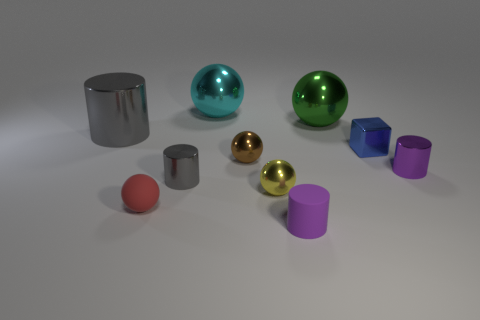Subtract all purple shiny cylinders. How many cylinders are left? 3 Subtract all gray balls. How many gray cylinders are left? 2 Subtract all cyan spheres. How many spheres are left? 4 Subtract 2 cylinders. How many cylinders are left? 2 Subtract all cylinders. How many objects are left? 6 Subtract 0 purple blocks. How many objects are left? 10 Subtract all blue cylinders. Subtract all blue spheres. How many cylinders are left? 4 Subtract all big green shiny spheres. Subtract all cyan metal balls. How many objects are left? 8 Add 5 metallic cylinders. How many metallic cylinders are left? 8 Add 3 cyan objects. How many cyan objects exist? 4 